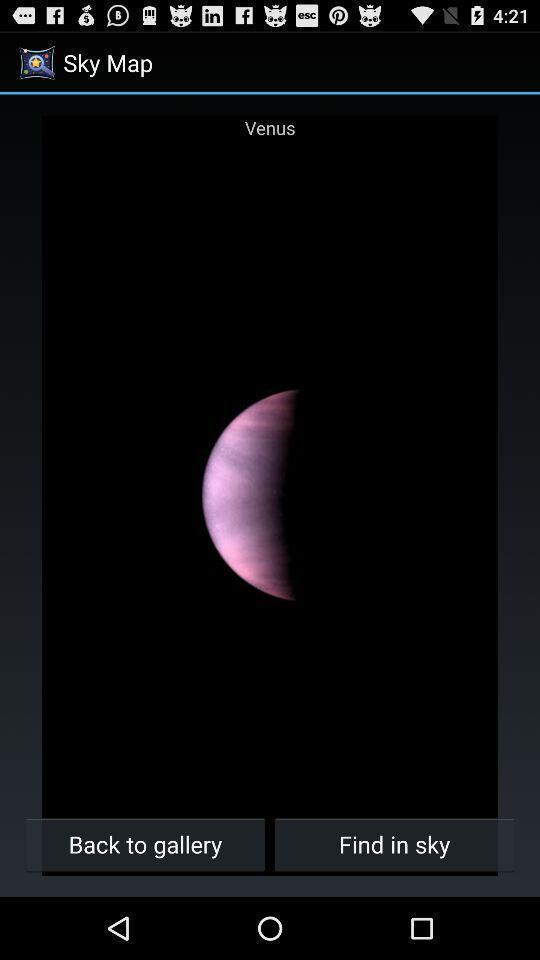What details can you identify in this image? Screen showing venus planet image. 